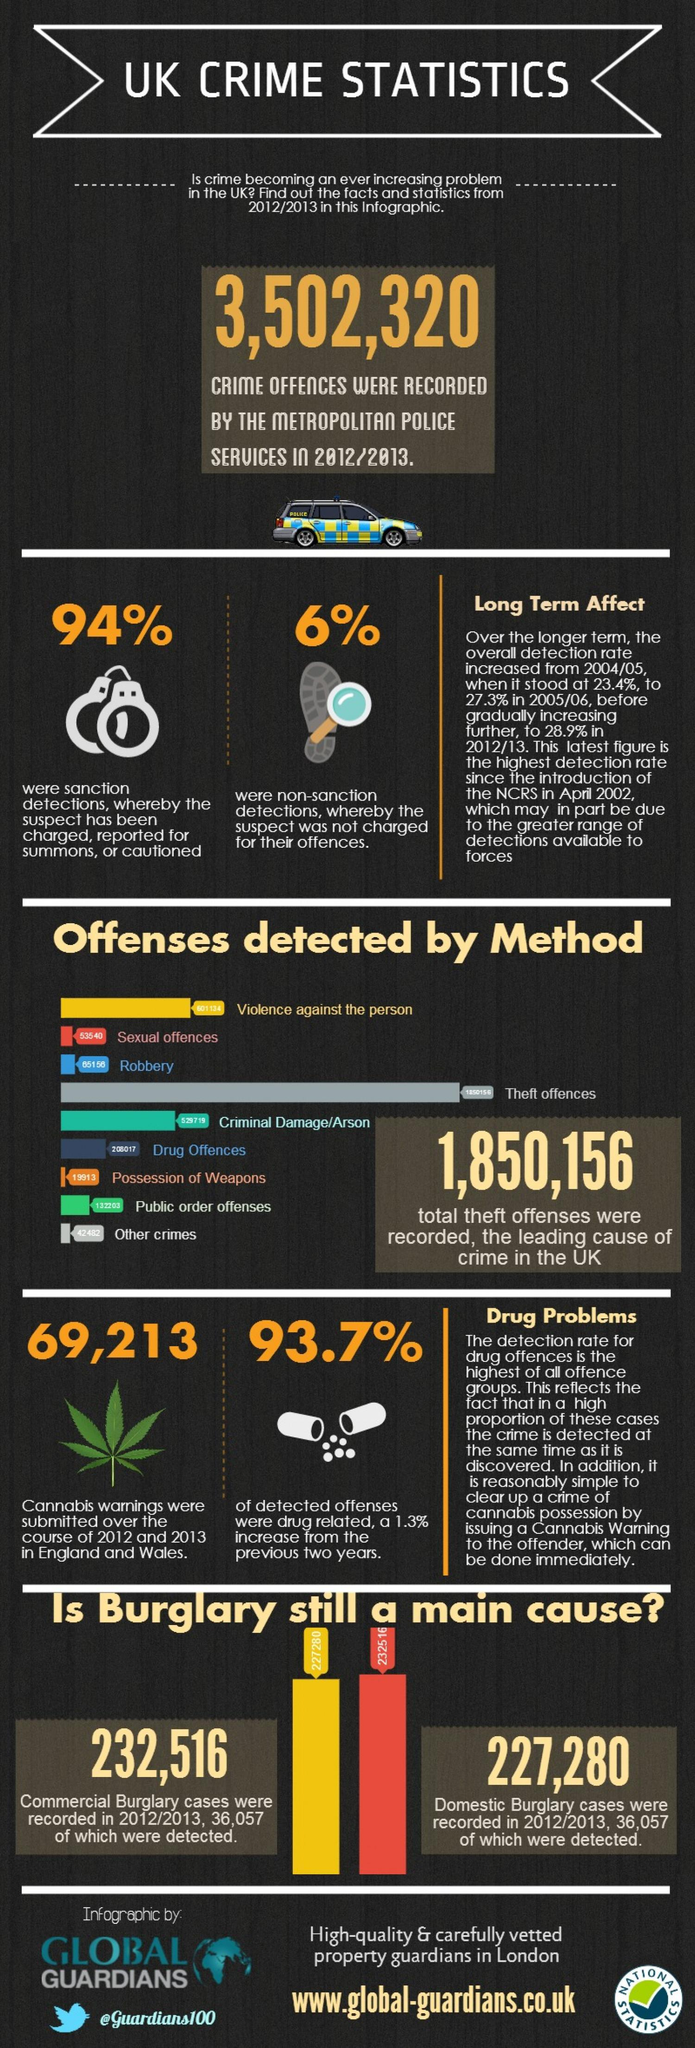Point out several critical features in this image. The crime that is highlighted in red and referred to as "Sexual Offences" is the one that stands out. Out of all detected offenses, only 6.3% were not drug-related. In the year 2012/13, there were significantly more commercial burglary cases reported than domestic burglary cases, with a difference of 5,236 cases. The color that depicts robbery offenses is blue. In the 2012-2013 fiscal year, a total of 459,796 commercial and domestic burglaries were reported. 